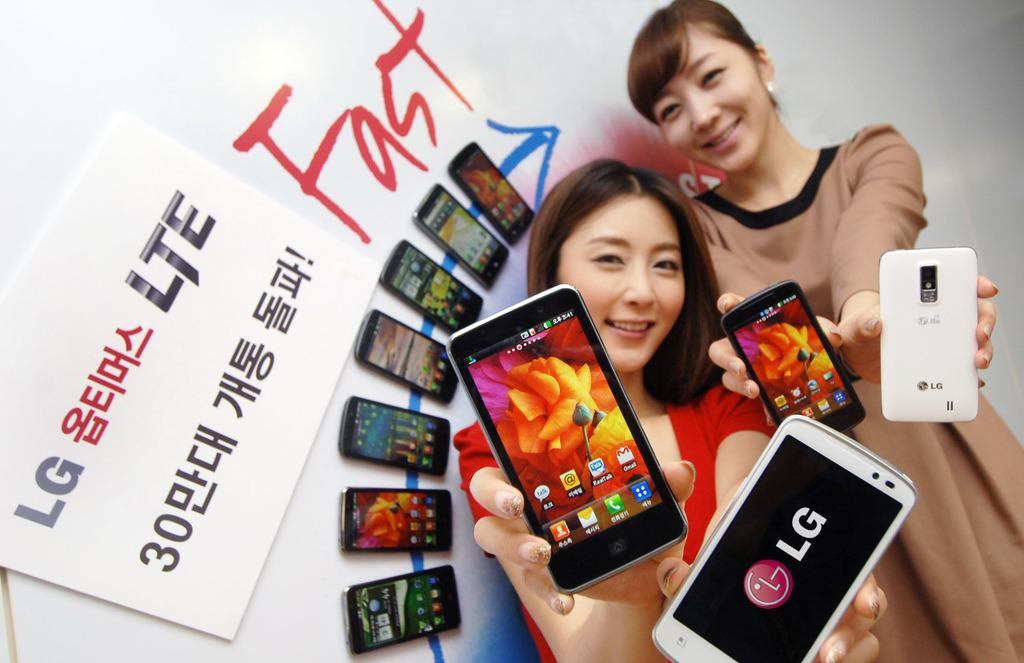<image>
Offer a succinct explanation of the picture presented. Two Japanes girls hold out their LG phones for us to see whilst standing in front of a promotional poster. 